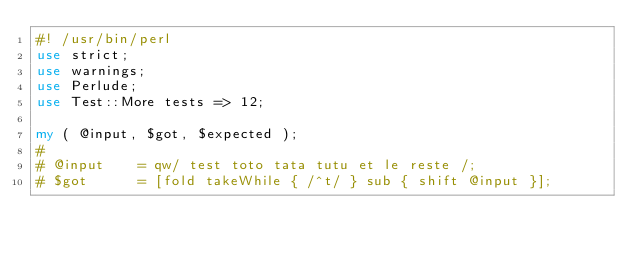<code> <loc_0><loc_0><loc_500><loc_500><_Perl_>#! /usr/bin/perl
use strict;
use warnings;
use Perlude;
use Test::More tests => 12;

my ( @input, $got, $expected );
# 
# @input    = qw/ test toto tata tutu et le reste /;
# $got      = [fold takeWhile { /^t/ } sub { shift @input }];</code> 